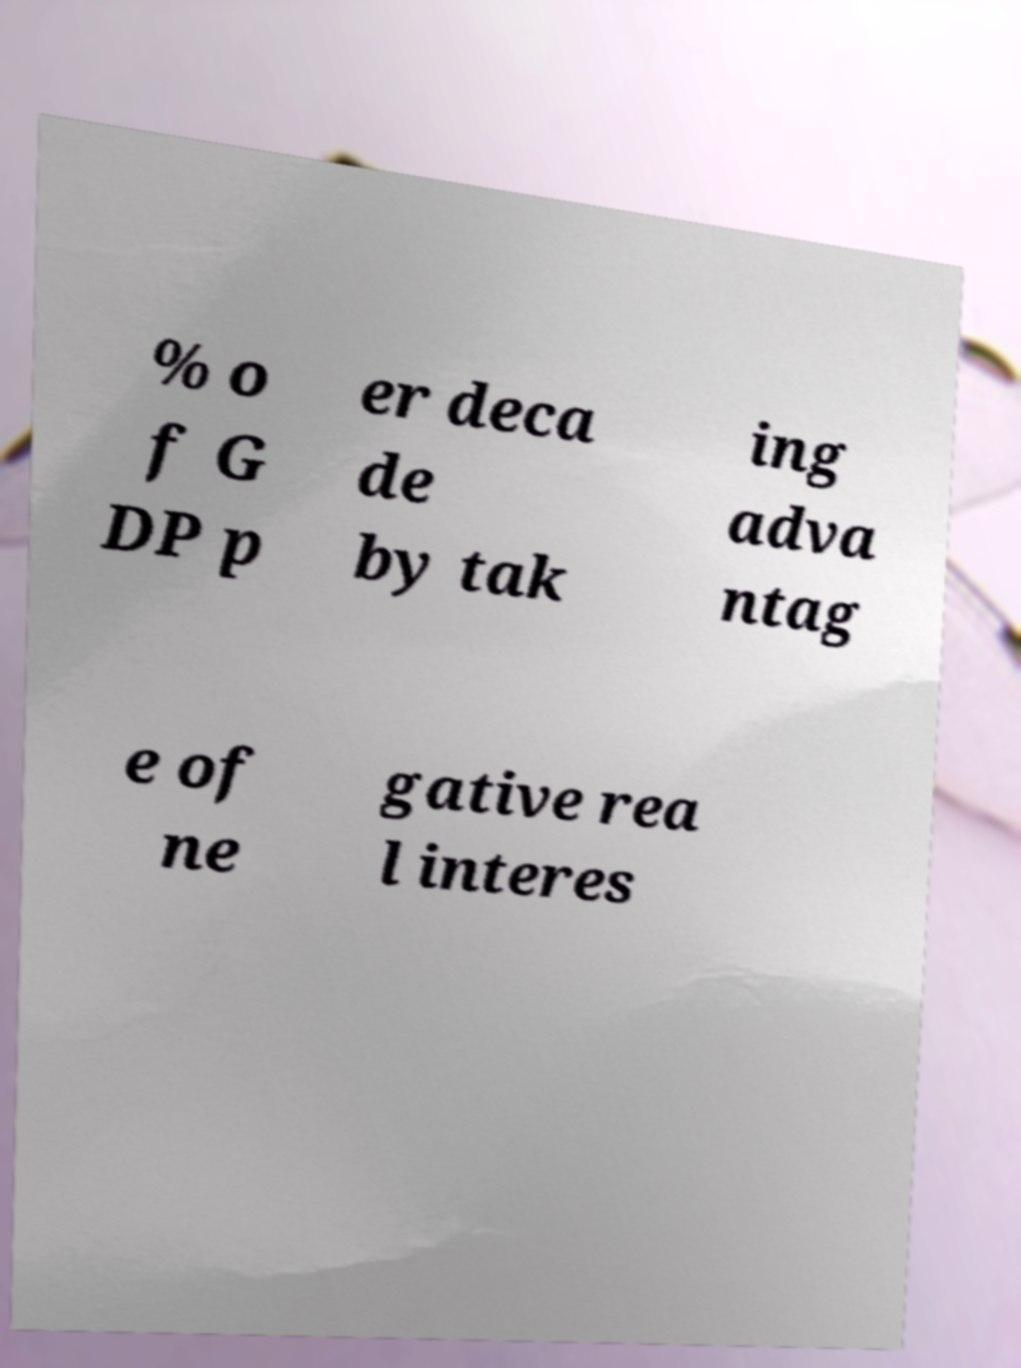Can you accurately transcribe the text from the provided image for me? % o f G DP p er deca de by tak ing adva ntag e of ne gative rea l interes 